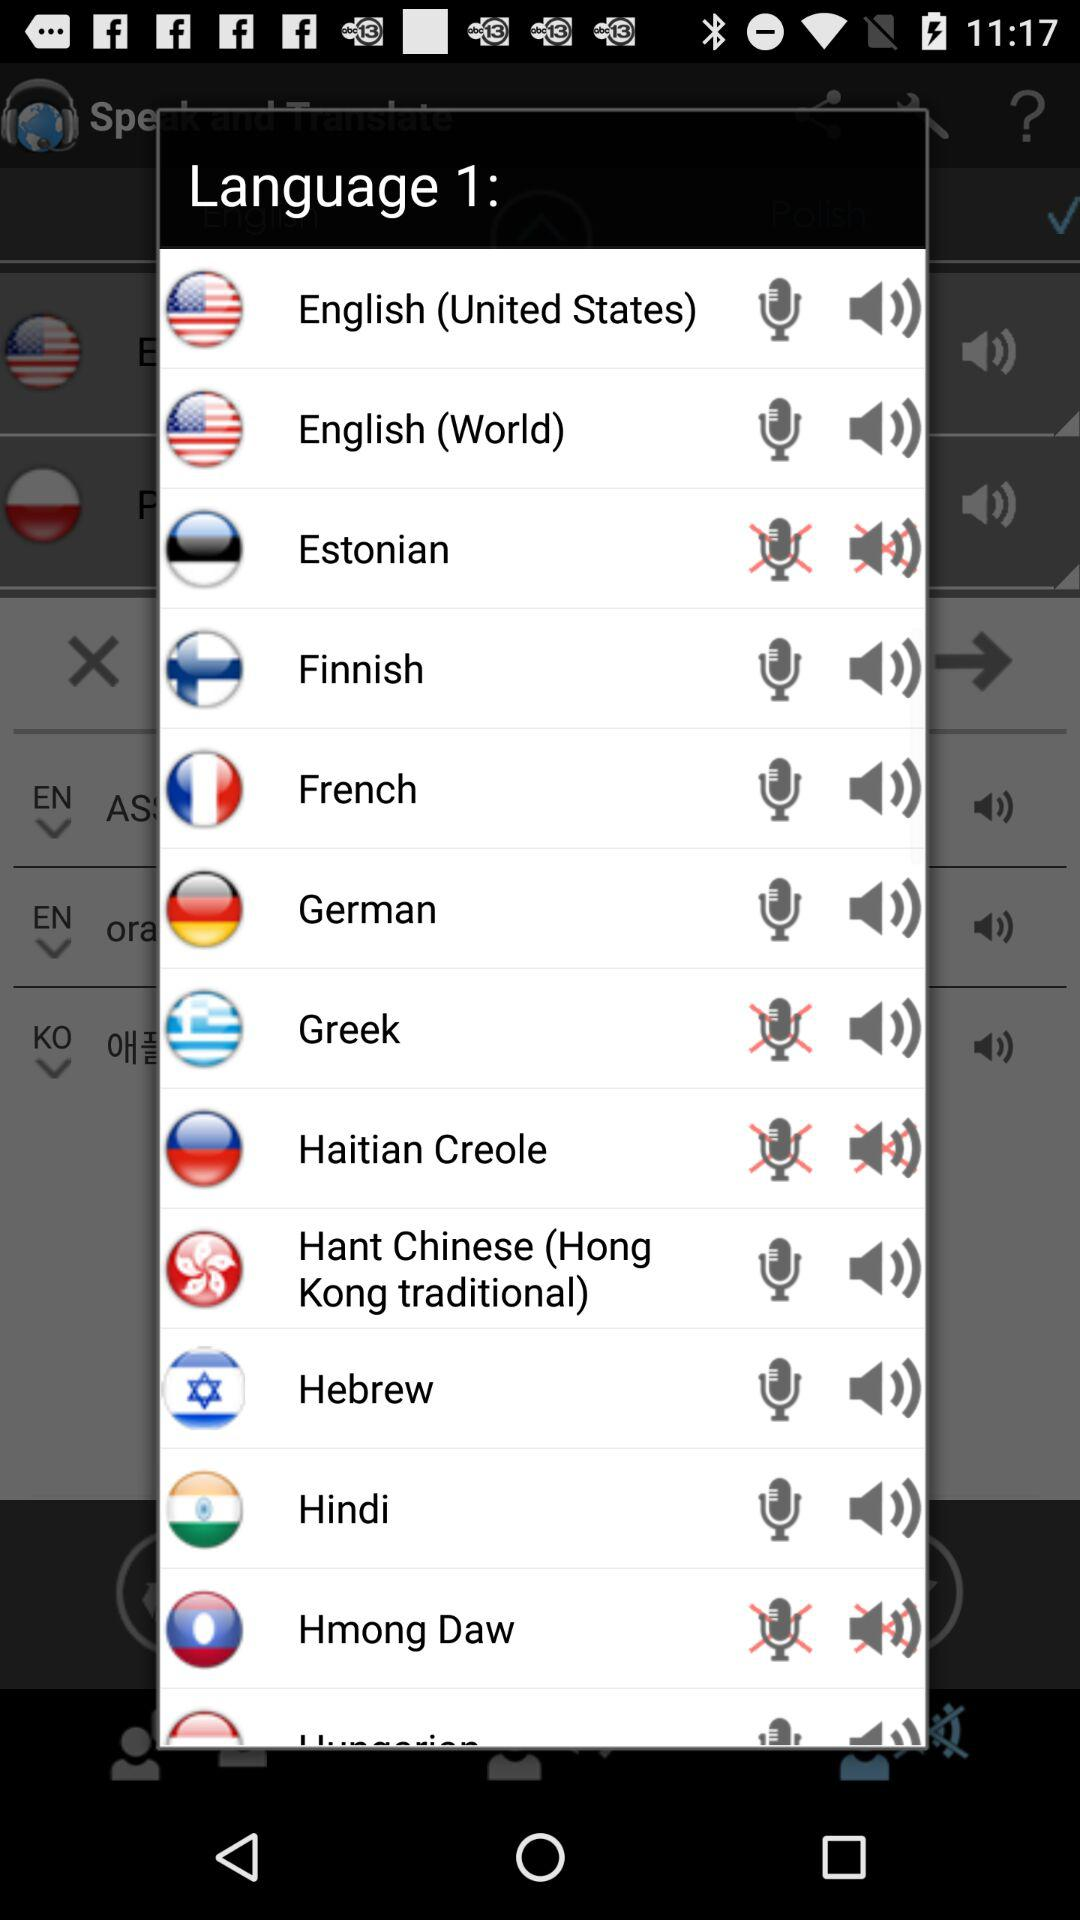Which menu item is selected?
When the provided information is insufficient, respond with <no answer>. <no answer> 